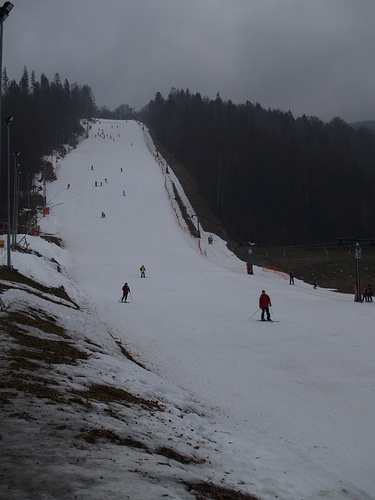Describe the objects in this image and their specific colors. I can see people in gray, black, and maroon tones, people in gray and black tones, people in gray and black tones, people in gray, black, and darkgray tones, and people in gray, black, and olive tones in this image. 